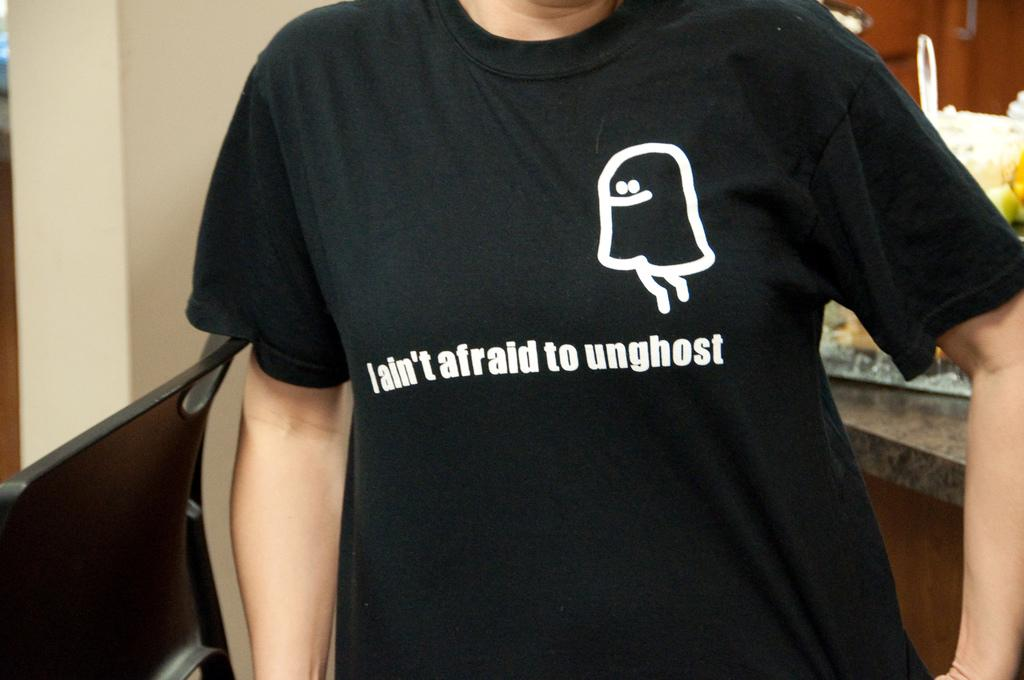<image>
Write a terse but informative summary of the picture. A black t-shirts states, "I ain't afraid to unghost". 